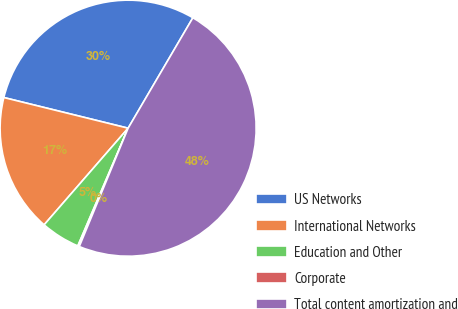Convert chart. <chart><loc_0><loc_0><loc_500><loc_500><pie_chart><fcel>US Networks<fcel>International Networks<fcel>Education and Other<fcel>Corporate<fcel>Total content amortization and<nl><fcel>29.59%<fcel>17.46%<fcel>4.96%<fcel>0.2%<fcel>47.79%<nl></chart> 